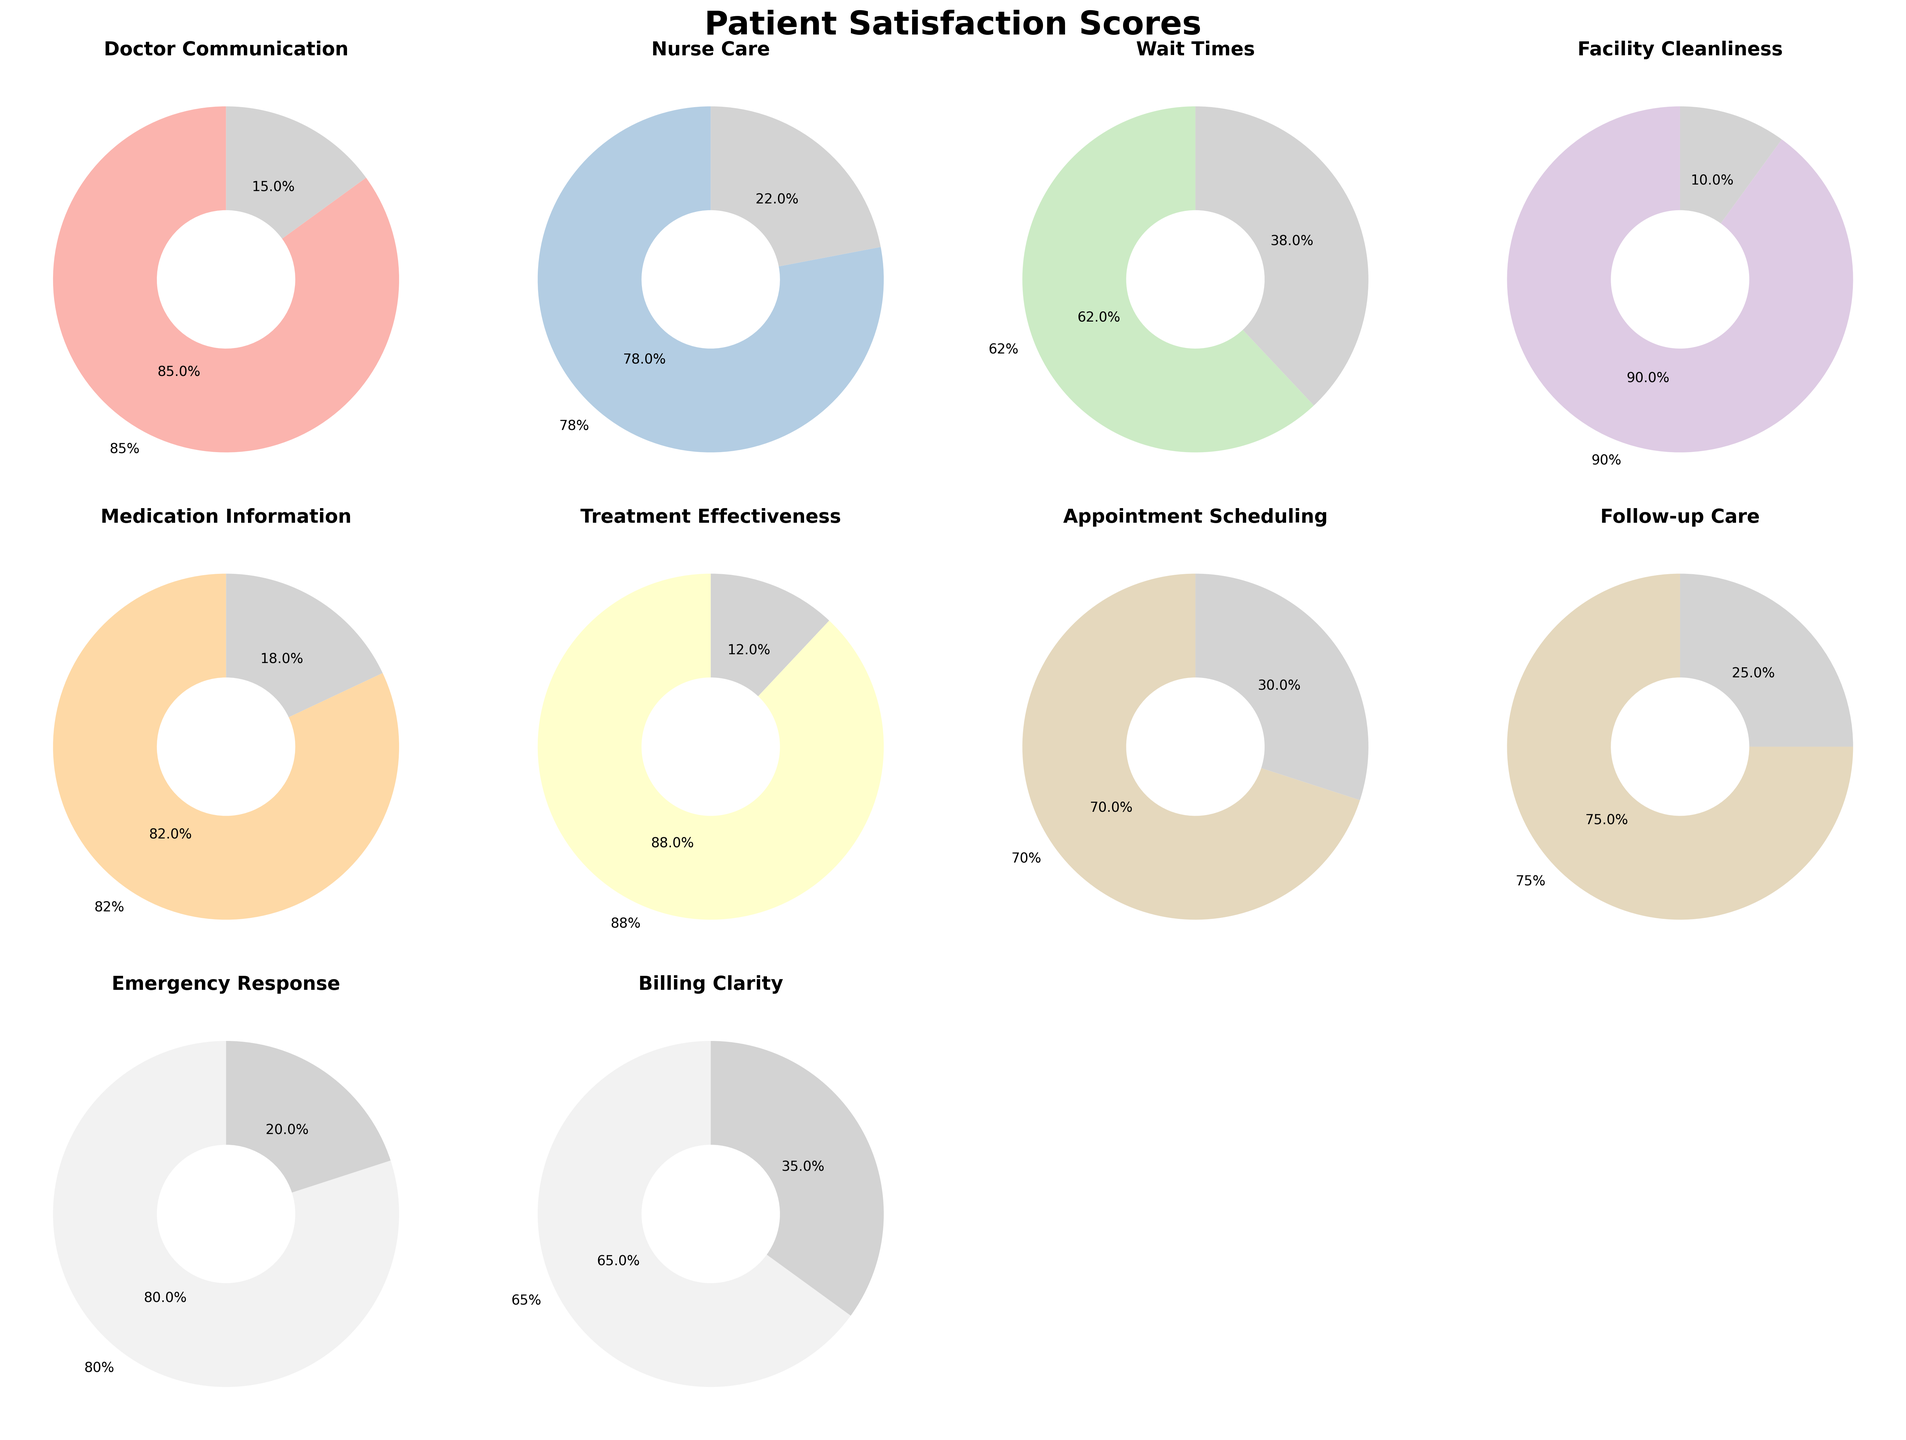What is the highest patient satisfaction score reported among the aspects? Looking at the pie charts, identify the one with the highest percentage label. The highest percentage corresponds to Facility Cleanliness with a score of 90%.
Answer: 90% Which aspect of healthcare services has the lowest satisfaction score? Identify the pie chart with the smallest percentage label. The lowest percentage is seen in Wait Times with a score of 62%.
Answer: 62% What is the combined patient satisfaction score for Doctor Communication and Treatment Effectiveness? Identify the scores for Doctor Communication (85) and Treatment Effectiveness (88). Adding them together gives 85 + 88 = 173.
Answer: 173 How does the patient satisfaction score for Billing Clarity compare to the score for Appointment Scheduling? Compare the two scores: Billing Clarity has a score of 65, while Appointment Scheduling has a score of 70. Billing Clarity's score is lower.
Answer: Billing Clarity is lower What is the average satisfaction score for the listed aspects of healthcare services? Sum all the satisfaction scores: 85 + 78 + 62 + 90 + 82 + 88 + 70 + 75 + 80 + 65 = 775. There are 10 aspects, so divide the total by 10: 775 / 10 = 77.5.
Answer: 77.5 Which three aspects have the highest satisfaction scores? Identify the three pie charts with the highest percentages: Facility Cleanliness (90), Treatment Effectiveness (88), and Doctor Communication (85).
Answer: Facility Cleanliness, Treatment Effectiveness, Doctor Communication What is the difference between the highest and the lowest patient satisfaction scores? Identify the highest score (Facility Cleanliness, 90) and the lowest score (Wait Times, 62). Subtract the lowest from the highest: 90 - 62 = 28.
Answer: 28 What fraction of the total aspects have a satisfaction score above 80%? Count the aspects with scores above 80: Doctor Communication (85), Facility Cleanliness (90), Medication Information (82), Treatment Effectiveness (88), and Emergency Response (80). There are 5 out of 10 aspects. Thus, the fraction is 5/10 or 1/2.
Answer: 1/2 How much higher is the patient satisfaction score for Nurse Care compared to Follow-up Care? Identify the scores for Nurse Care (78) and Follow-up Care (75). Subtract the lower score from the higher score: 78 - 75 = 3.
Answer: 3 Which aspect has a slightly better satisfaction score, Emergency Response or Medication Information? Compare the scores for Emergency Response (80) and Medication Information (82). Medication Information is slightly better.
Answer: Medication Information 